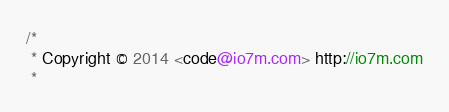Convert code to text. <code><loc_0><loc_0><loc_500><loc_500><_Java_>/*
 * Copyright © 2014 <code@io7m.com> http://io7m.com
 * </code> 